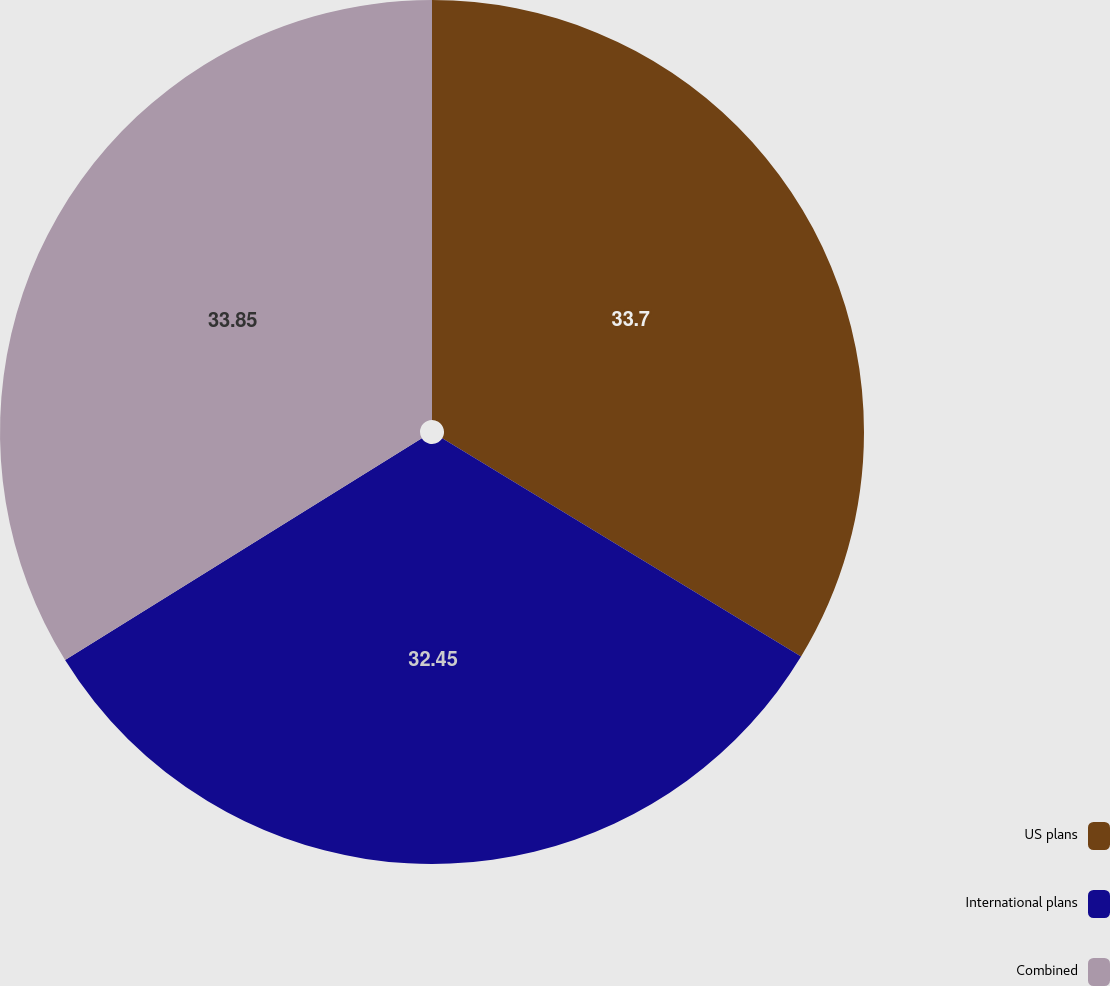Convert chart to OTSL. <chart><loc_0><loc_0><loc_500><loc_500><pie_chart><fcel>US plans<fcel>International plans<fcel>Combined<nl><fcel>33.7%<fcel>32.45%<fcel>33.85%<nl></chart> 